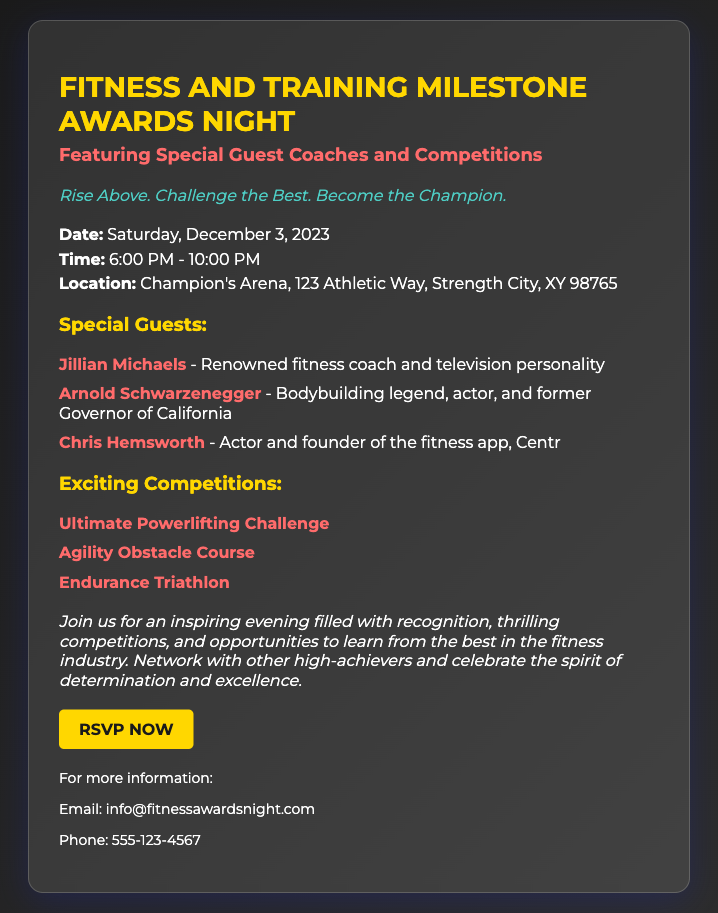what date is the event? The event date is specifically mentioned in the details section of the document as Saturday, December 3, 2023.
Answer: December 3, 2023 what time does the event start? The starting time of the event is listed in the details section as 6:00 PM.
Answer: 6:00 PM where is the awards night being held? The location of the event is provided in the details section, with a complete address mentioned.
Answer: Champion's Arena, 123 Athletic Way, Strength City, XY 98765 who is one of the special guest coaches? The document lists three special guests, but one notable guest is mentioned as Jillian Michaels.
Answer: Jillian Michaels what is one of the competitions listed? The competitions section includes several challenges, including the Ultimate Powerlifting Challenge.
Answer: Ultimate Powerlifting Challenge how many competitions are mentioned? The total number of competitions can be tallied from the list provided in the document, which displays three competitions.
Answer: 3 what is the tagline of the event? The tagline is stated prominently in the document, emphasizing the theme of the event.
Answer: Rise Above. Challenge the Best. Become the Champion what type of event is this document for? The document is specifically designed for an awards night in a fitness and training context, as highlighted in the title.
Answer: Fitness and Training Milestone Awards Night how can someone RSVP for the event? The document includes a call-to-action with a link where individuals can confirm their attendance.
Answer: RSVP Now 